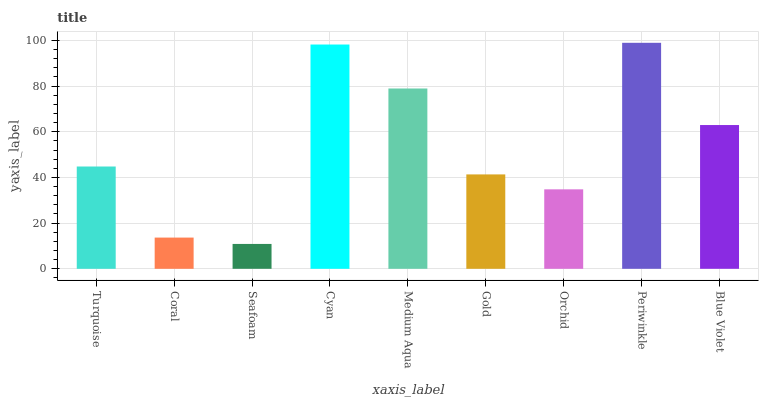Is Seafoam the minimum?
Answer yes or no. Yes. Is Periwinkle the maximum?
Answer yes or no. Yes. Is Coral the minimum?
Answer yes or no. No. Is Coral the maximum?
Answer yes or no. No. Is Turquoise greater than Coral?
Answer yes or no. Yes. Is Coral less than Turquoise?
Answer yes or no. Yes. Is Coral greater than Turquoise?
Answer yes or no. No. Is Turquoise less than Coral?
Answer yes or no. No. Is Turquoise the high median?
Answer yes or no. Yes. Is Turquoise the low median?
Answer yes or no. Yes. Is Orchid the high median?
Answer yes or no. No. Is Orchid the low median?
Answer yes or no. No. 